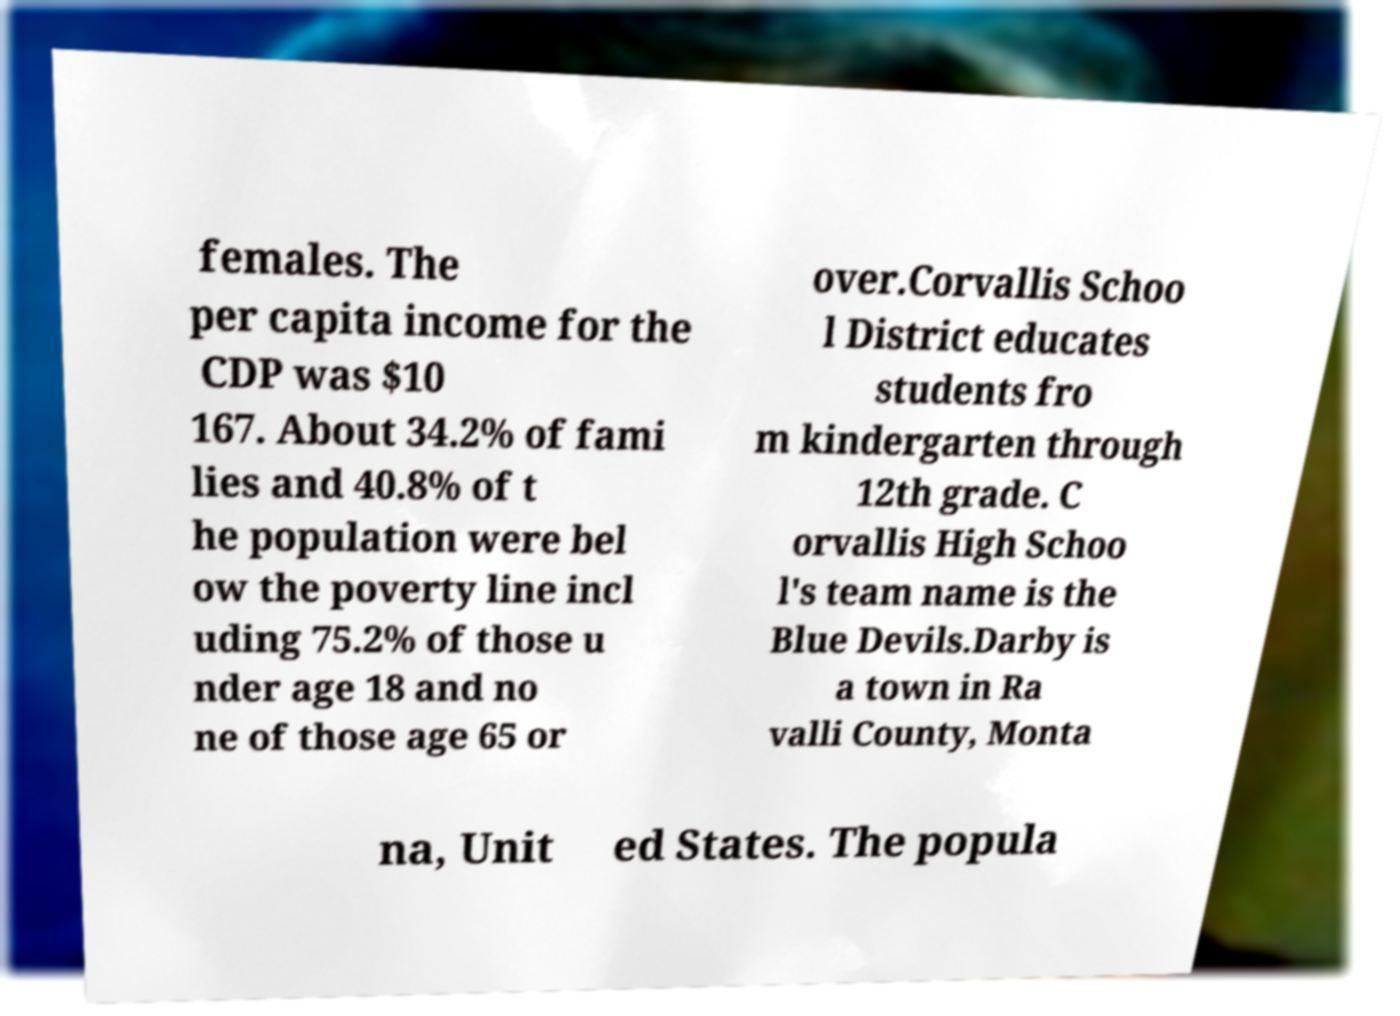Can you read and provide the text displayed in the image?This photo seems to have some interesting text. Can you extract and type it out for me? females. The per capita income for the CDP was $10 167. About 34.2% of fami lies and 40.8% of t he population were bel ow the poverty line incl uding 75.2% of those u nder age 18 and no ne of those age 65 or over.Corvallis Schoo l District educates students fro m kindergarten through 12th grade. C orvallis High Schoo l's team name is the Blue Devils.Darby is a town in Ra valli County, Monta na, Unit ed States. The popula 